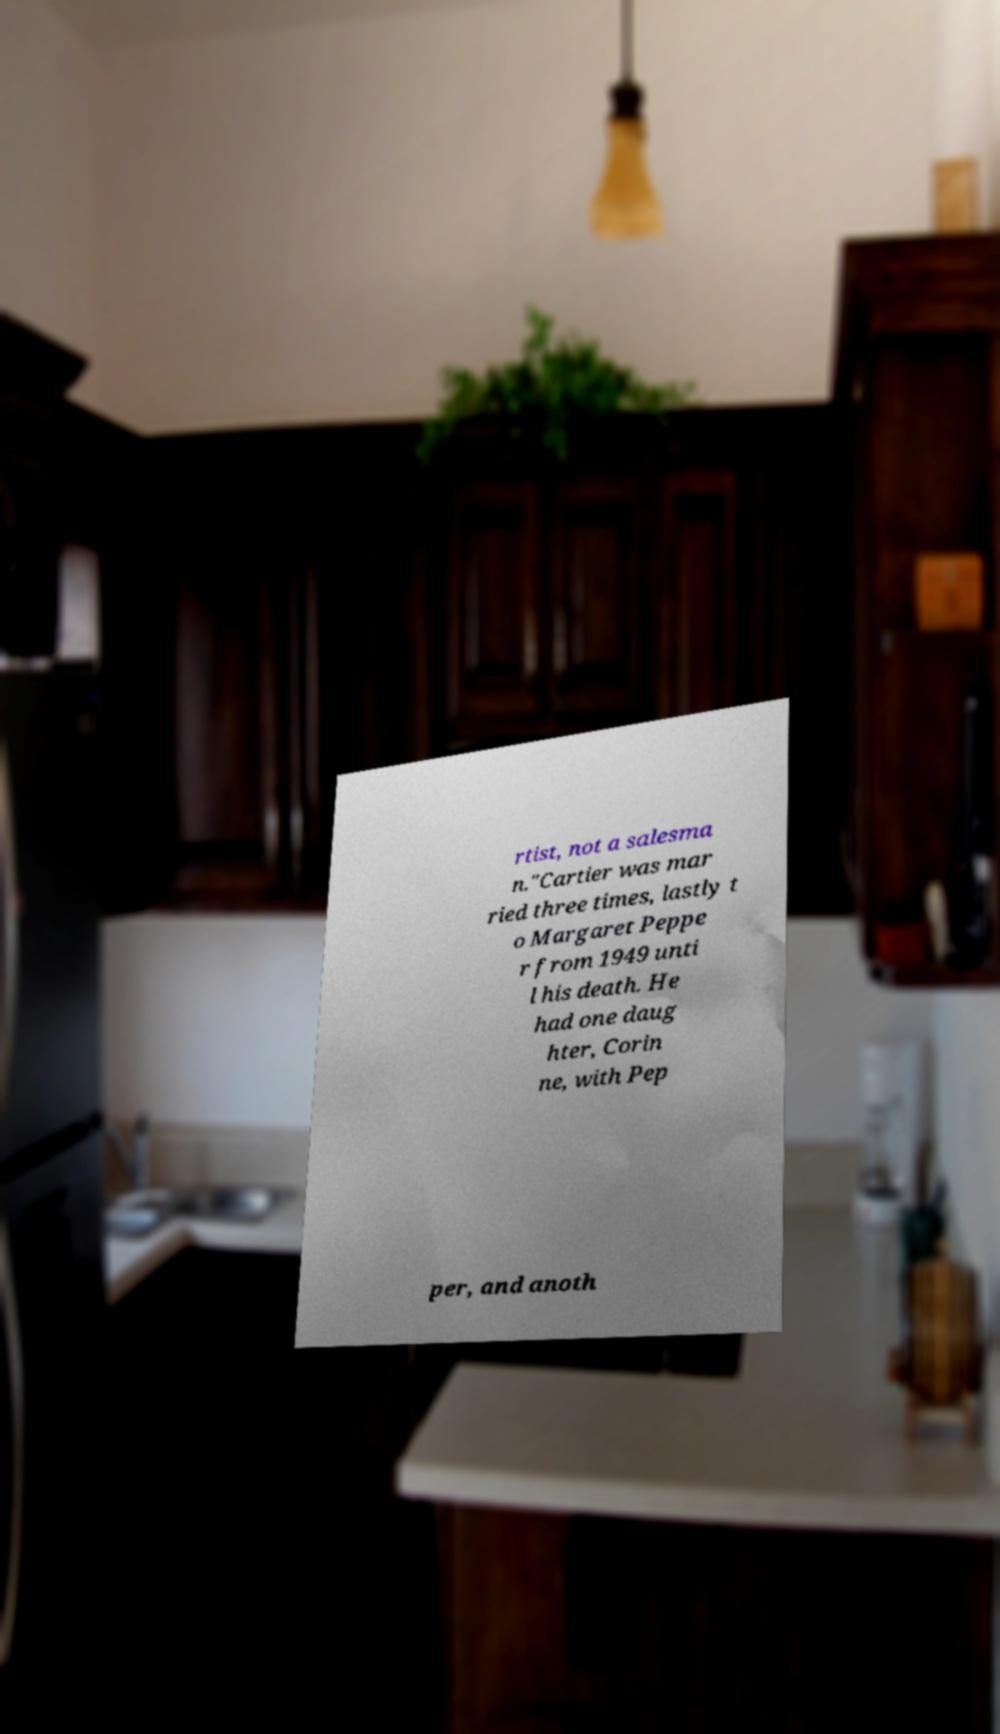I need the written content from this picture converted into text. Can you do that? rtist, not a salesma n."Cartier was mar ried three times, lastly t o Margaret Peppe r from 1949 unti l his death. He had one daug hter, Corin ne, with Pep per, and anoth 